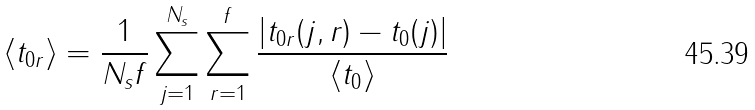<formula> <loc_0><loc_0><loc_500><loc_500>\langle t _ { 0 r } \rangle = \frac { 1 } { N _ { s } f } \sum _ { j = 1 } ^ { N _ { s } } \sum _ { r = 1 } ^ { f } \frac { | t _ { 0 r } ( j , r ) - t _ { 0 } ( j ) | } { \langle t _ { 0 } \rangle }</formula> 